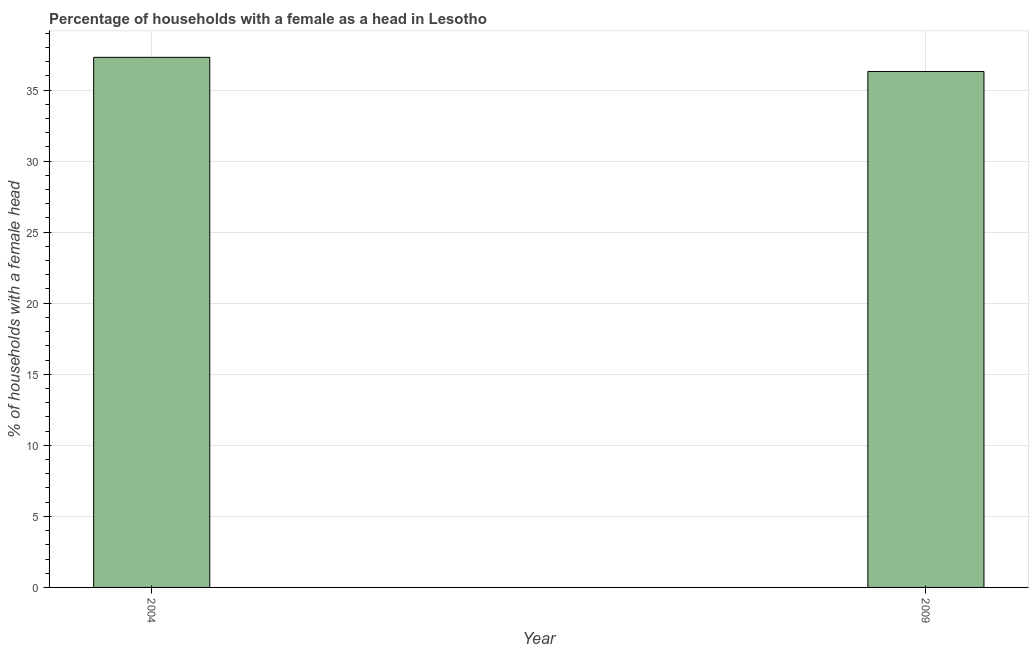Does the graph contain any zero values?
Make the answer very short. No. Does the graph contain grids?
Provide a succinct answer. Yes. What is the title of the graph?
Ensure brevity in your answer.  Percentage of households with a female as a head in Lesotho. What is the label or title of the X-axis?
Your answer should be compact. Year. What is the label or title of the Y-axis?
Your response must be concise. % of households with a female head. What is the number of female supervised households in 2004?
Give a very brief answer. 37.3. Across all years, what is the maximum number of female supervised households?
Give a very brief answer. 37.3. Across all years, what is the minimum number of female supervised households?
Make the answer very short. 36.3. In which year was the number of female supervised households maximum?
Your answer should be compact. 2004. In which year was the number of female supervised households minimum?
Your response must be concise. 2009. What is the sum of the number of female supervised households?
Ensure brevity in your answer.  73.6. What is the average number of female supervised households per year?
Your answer should be compact. 36.8. What is the median number of female supervised households?
Provide a succinct answer. 36.8. What is the ratio of the number of female supervised households in 2004 to that in 2009?
Ensure brevity in your answer.  1.03. Is the number of female supervised households in 2004 less than that in 2009?
Make the answer very short. No. In how many years, is the number of female supervised households greater than the average number of female supervised households taken over all years?
Offer a very short reply. 1. How many bars are there?
Provide a succinct answer. 2. Are all the bars in the graph horizontal?
Offer a very short reply. No. Are the values on the major ticks of Y-axis written in scientific E-notation?
Your response must be concise. No. What is the % of households with a female head of 2004?
Keep it short and to the point. 37.3. What is the % of households with a female head in 2009?
Offer a very short reply. 36.3. What is the difference between the % of households with a female head in 2004 and 2009?
Your answer should be very brief. 1. What is the ratio of the % of households with a female head in 2004 to that in 2009?
Offer a terse response. 1.03. 